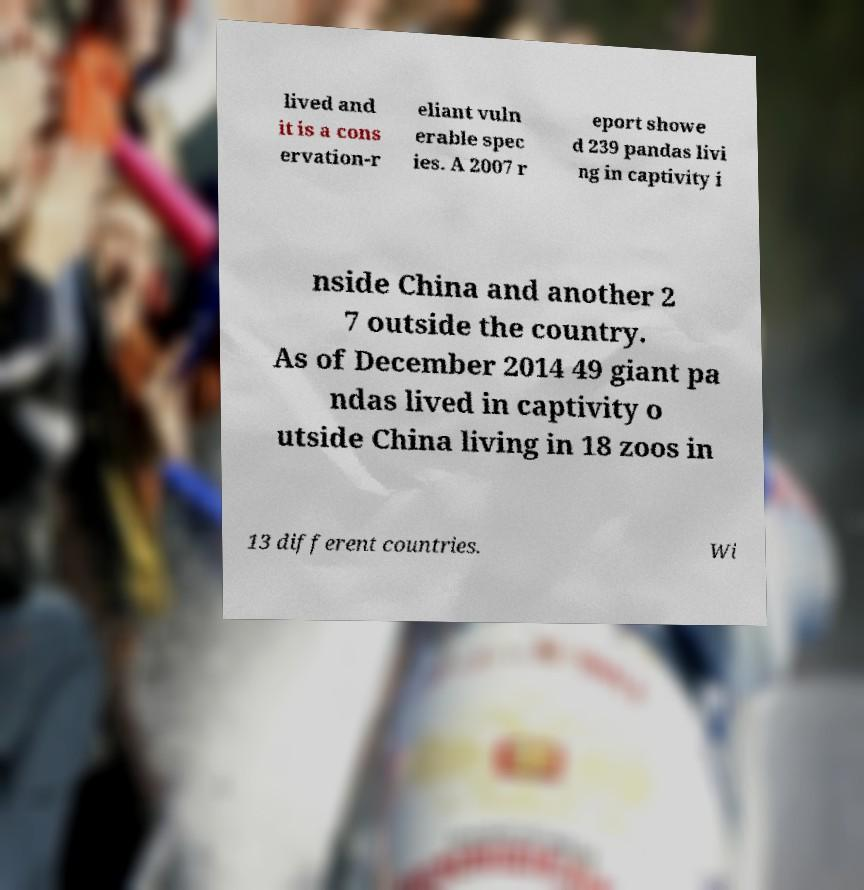Could you extract and type out the text from this image? lived and it is a cons ervation-r eliant vuln erable spec ies. A 2007 r eport showe d 239 pandas livi ng in captivity i nside China and another 2 7 outside the country. As of December 2014 49 giant pa ndas lived in captivity o utside China living in 18 zoos in 13 different countries. Wi 